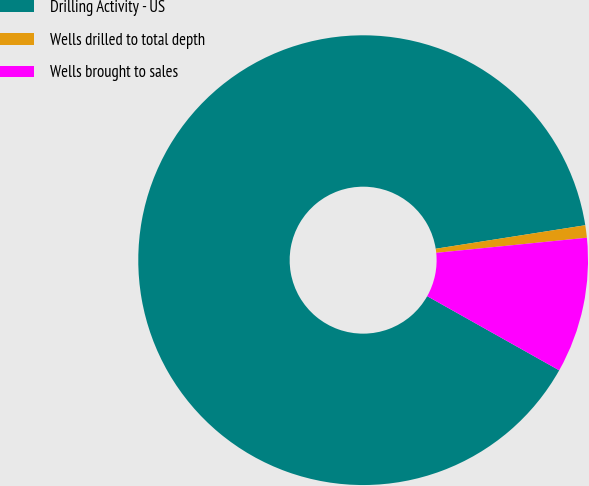<chart> <loc_0><loc_0><loc_500><loc_500><pie_chart><fcel>Drilling Activity - US<fcel>Wells drilled to total depth<fcel>Wells brought to sales<nl><fcel>89.38%<fcel>0.89%<fcel>9.74%<nl></chart> 